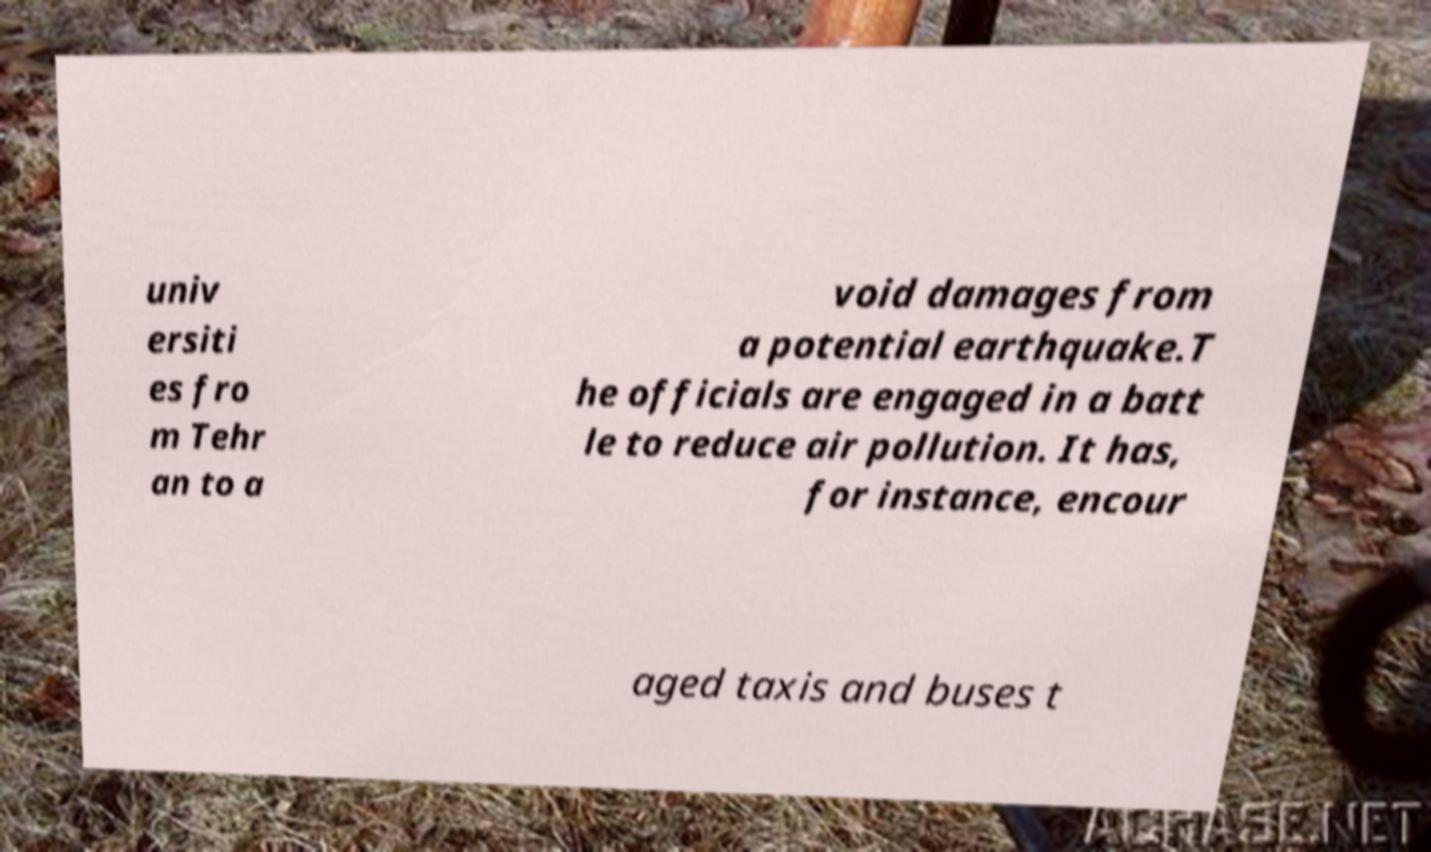For documentation purposes, I need the text within this image transcribed. Could you provide that? univ ersiti es fro m Tehr an to a void damages from a potential earthquake.T he officials are engaged in a batt le to reduce air pollution. It has, for instance, encour aged taxis and buses t 